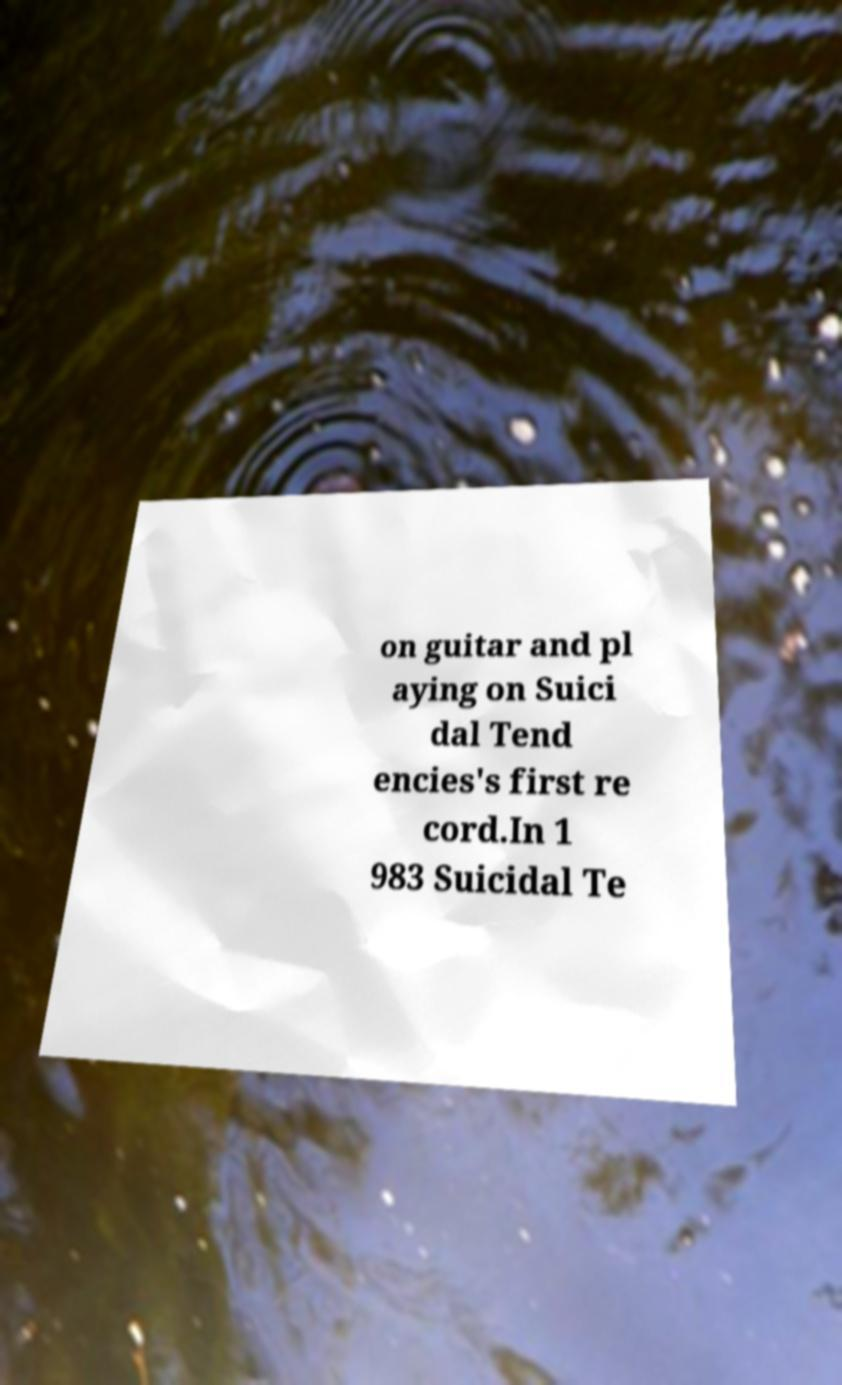Could you assist in decoding the text presented in this image and type it out clearly? on guitar and pl aying on Suici dal Tend encies's first re cord.In 1 983 Suicidal Te 